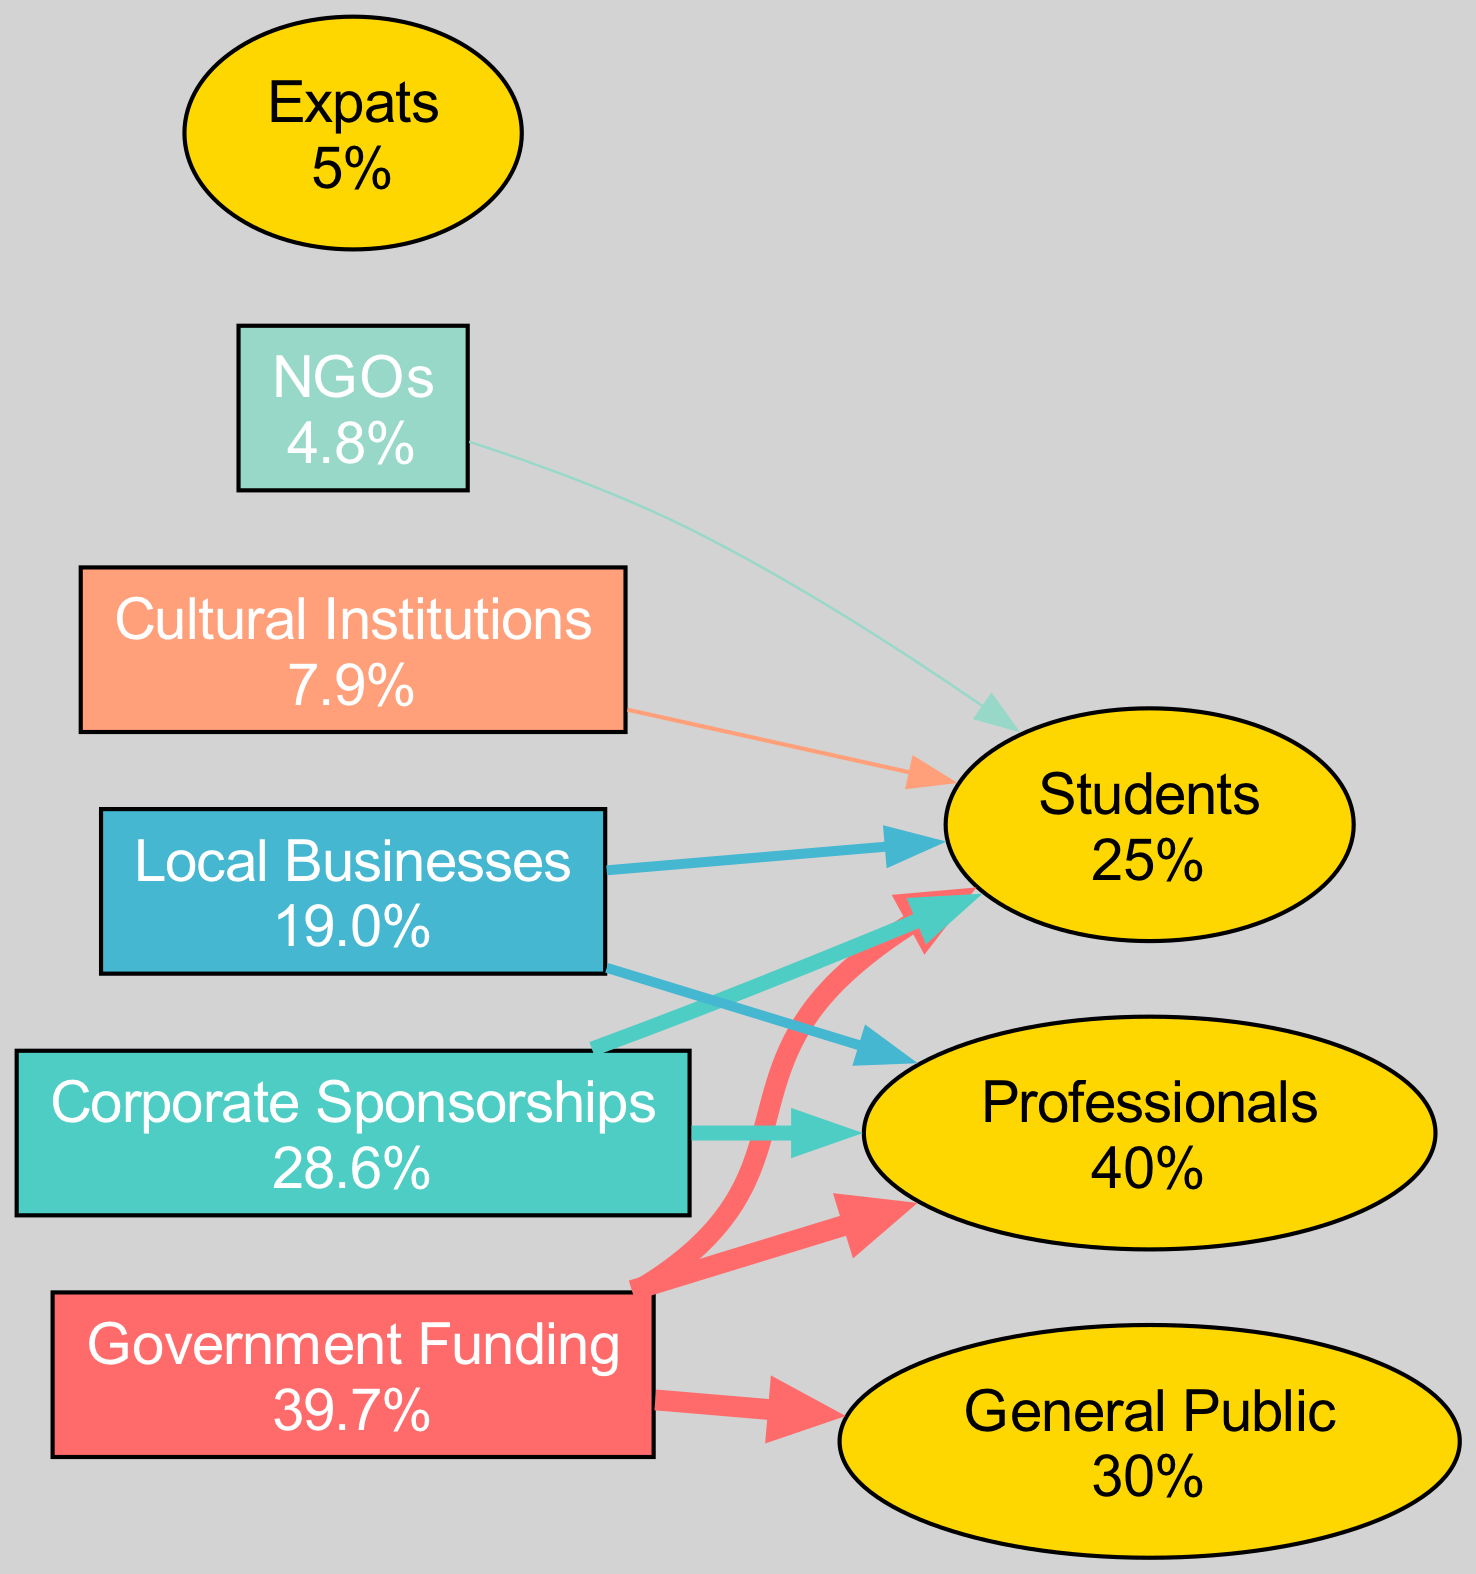What is the total revenue from Corporate Sponsorships? According to the data for Corporate Sponsorships, the revenue is explicitly provided as 1.8.
Answer: 1.8 Which sponsorship type has the highest audience reach? The diagram shows that Government Funding has a 'High' audience reach, which is the highest when compared to other sponsors.
Answer: Government Funding How many audience types are represented in the diagram? The diagram lists four audience types: Students, Professionals, General Public, and Expats. Therefore, the total is four.
Answer: 4 What revenue does Local Businesses contribute? The revenue for Local Businesses is stated in the data as 1.2.
Answer: 1.2 Which audience receives funding from Cultural Institutions? The diagram indicates that Cultural Institutions have a 'Low' reach, which corresponds to Students, so Students receive funding from them.
Answer: Students Which sponsorship type has the least revenue? The data shows that NGOs have the lowest revenue at 0.3, which represents the least among all sponsors.
Answer: NGOs What percentage of the audience does Professionals represent? The diagram specifies that Professionals represent 40% of the audience reach, as explicitly stated in the data.
Answer: 40% How many edges connect from Government Funding to audience types? Given that Government Funding has a 'High' audience reach, it connects to three audience types: Students, Professionals, and General Public, resulting in three edges.
Answer: 3 What is the revenue percentage of Cultural Institutions? The total revenue is 6.3, and Cultural Institutions contribute 0.5. Therefore, the revenue percentage is (0.5/6.3) * 100, which equals about 7.9%.
Answer: 7.9% 